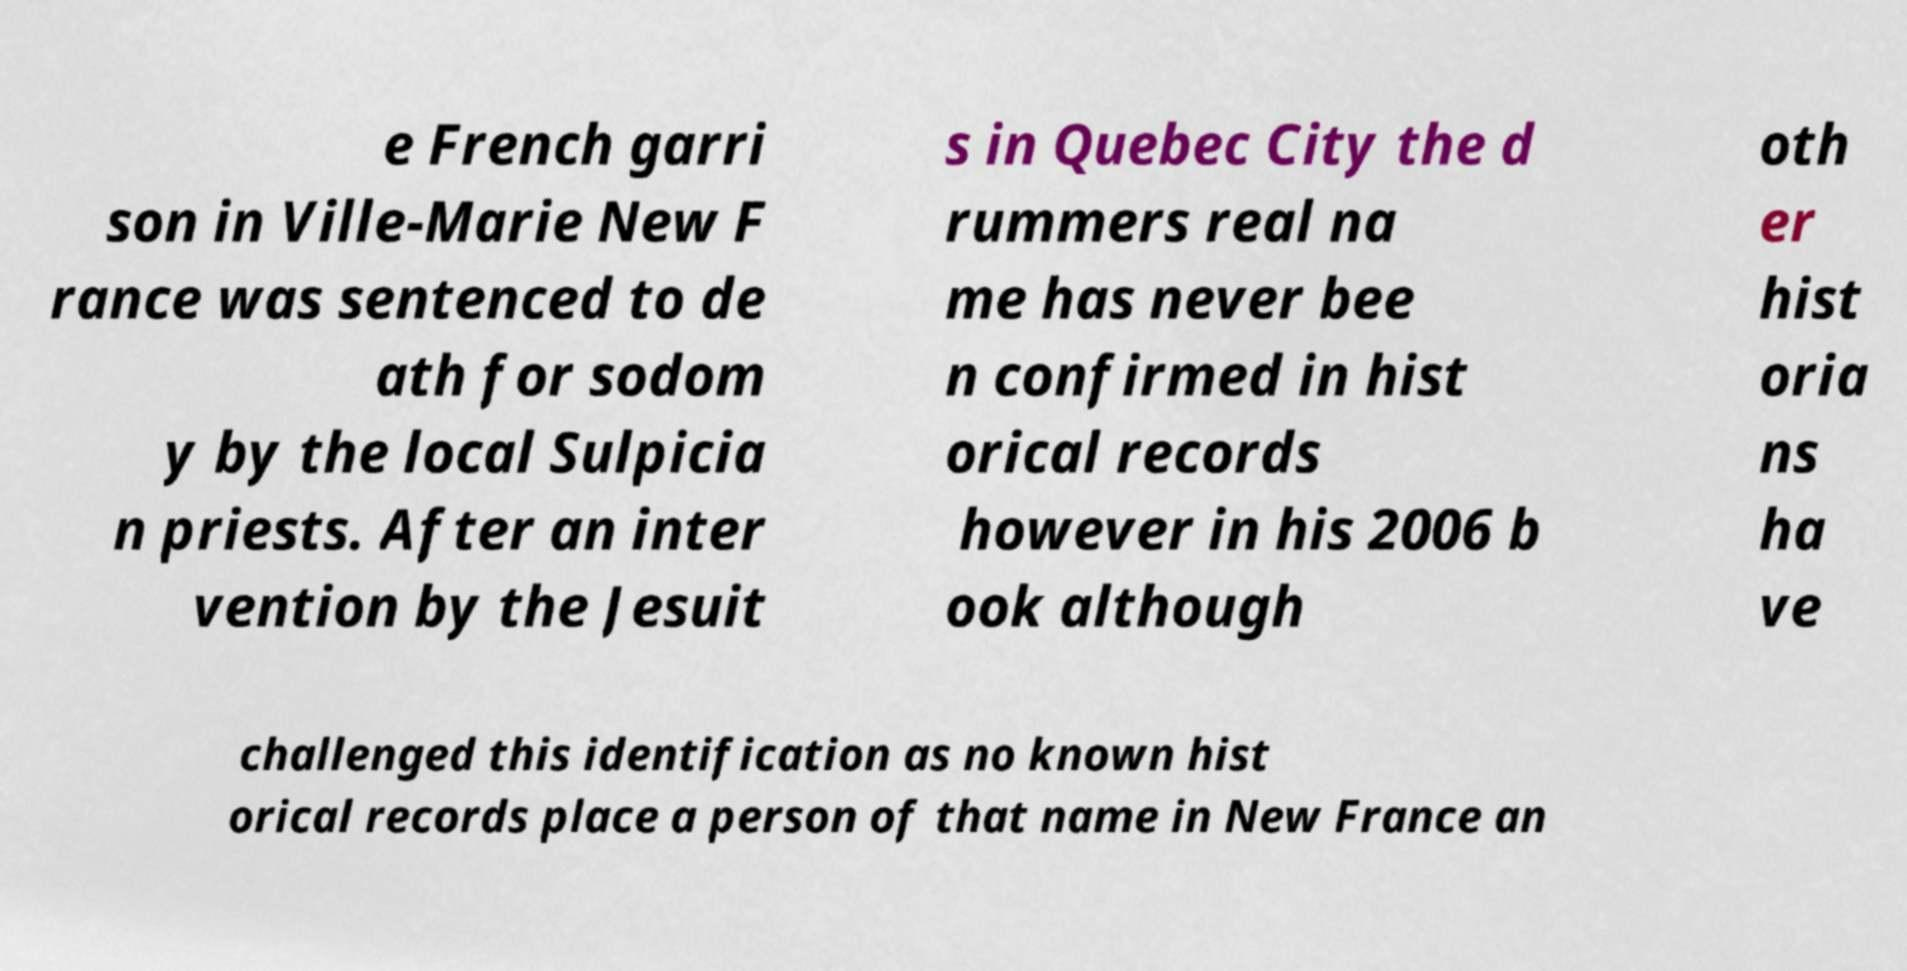For documentation purposes, I need the text within this image transcribed. Could you provide that? e French garri son in Ville-Marie New F rance was sentenced to de ath for sodom y by the local Sulpicia n priests. After an inter vention by the Jesuit s in Quebec City the d rummers real na me has never bee n confirmed in hist orical records however in his 2006 b ook although oth er hist oria ns ha ve challenged this identification as no known hist orical records place a person of that name in New France an 